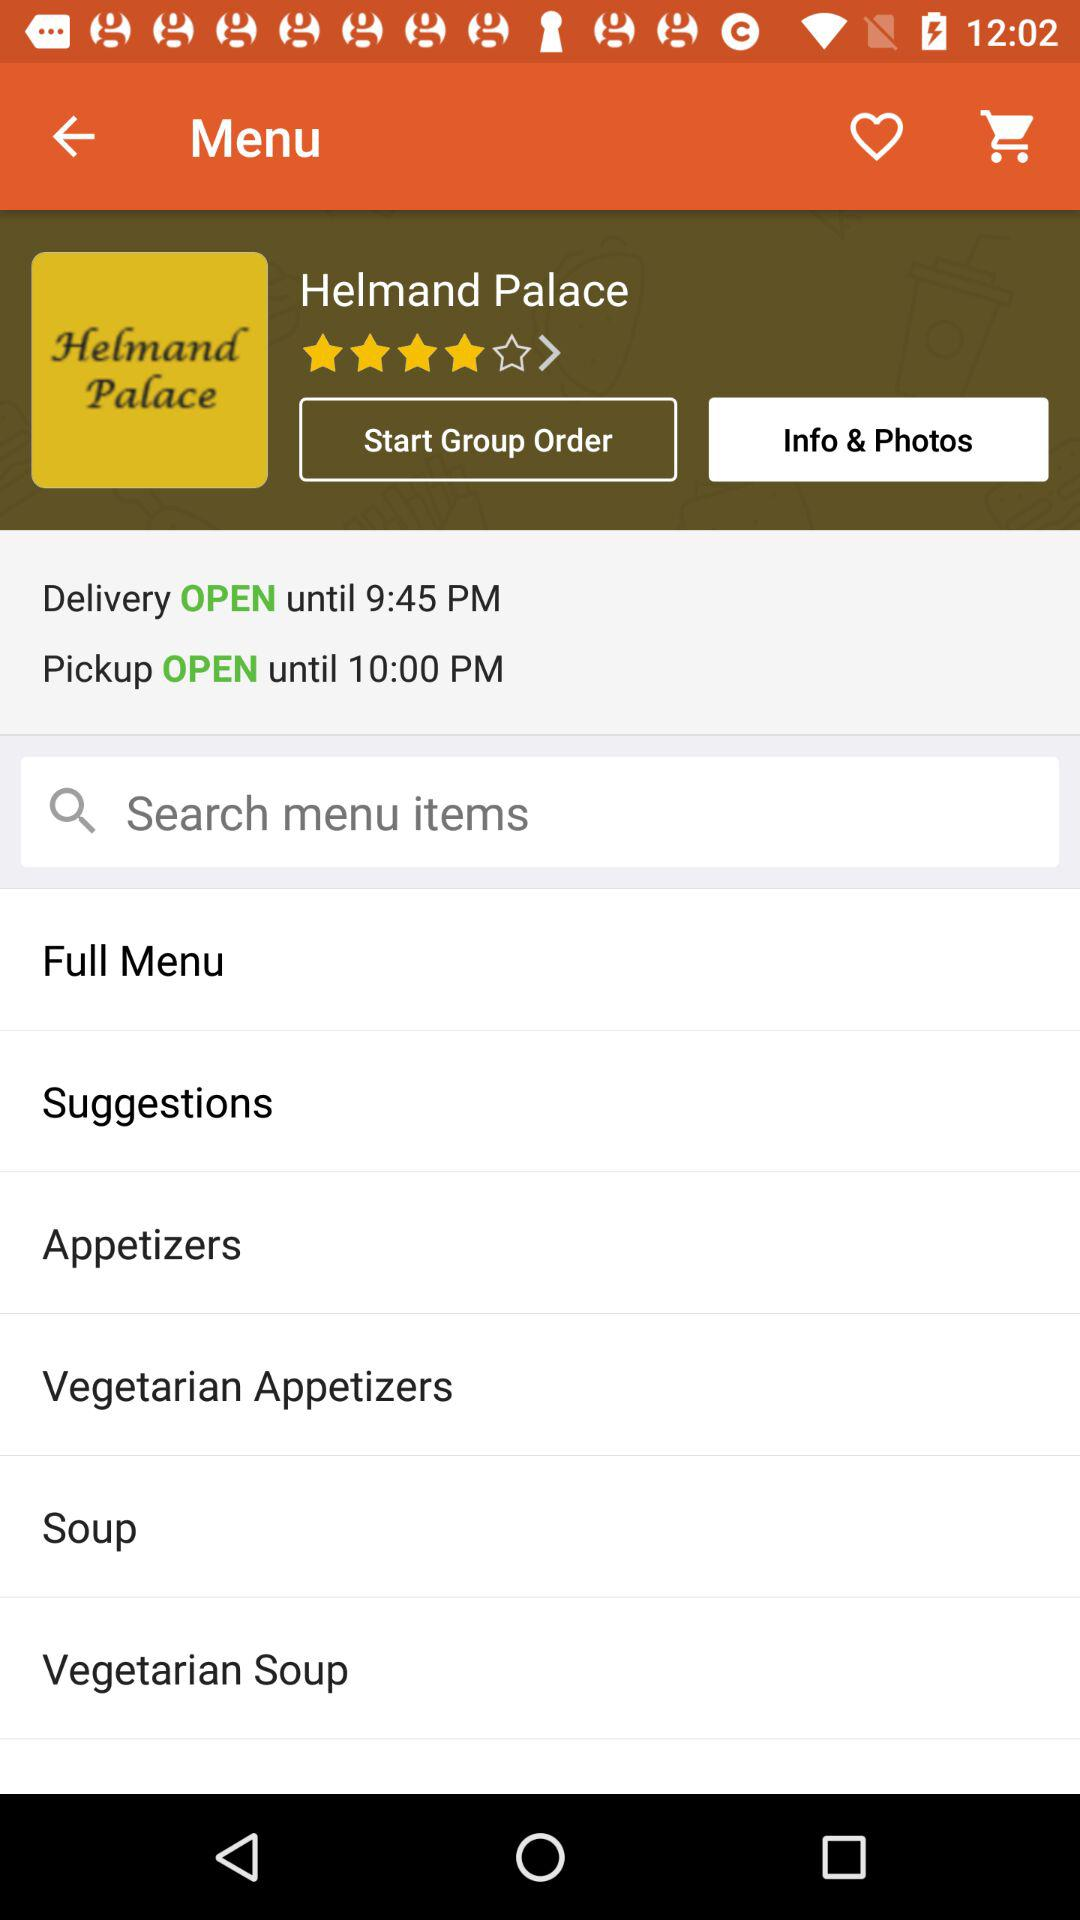Until when is the pickup open? The pickup is open until 10:00 p.m. 